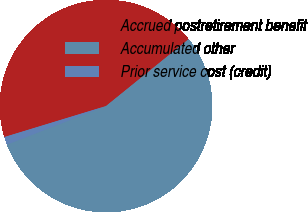Convert chart. <chart><loc_0><loc_0><loc_500><loc_500><pie_chart><fcel>Accrued postretirement benefit<fcel>Accumulated other<fcel>Prior service cost (credit)<nl><fcel>43.88%<fcel>54.92%<fcel>1.2%<nl></chart> 